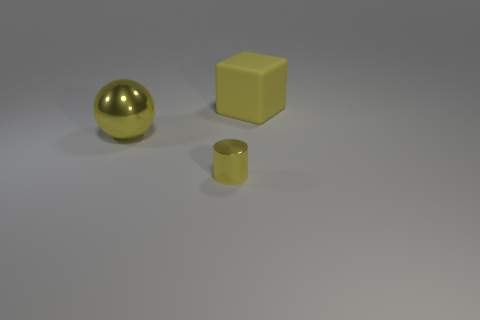Subtract all cylinders. How many objects are left? 2 Add 1 large gray matte blocks. How many objects exist? 4 Add 2 large objects. How many large objects exist? 4 Subtract 0 blue cubes. How many objects are left? 3 Subtract all tiny blue metallic things. Subtract all yellow balls. How many objects are left? 2 Add 1 big yellow shiny balls. How many big yellow shiny balls are left? 2 